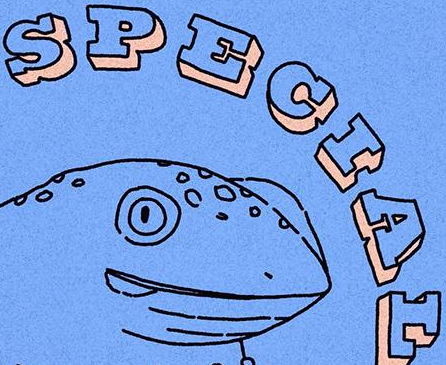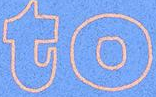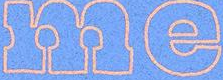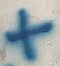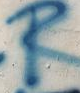What text appears in these images from left to right, separated by a semicolon? SPECIAL; to; me; +; R 